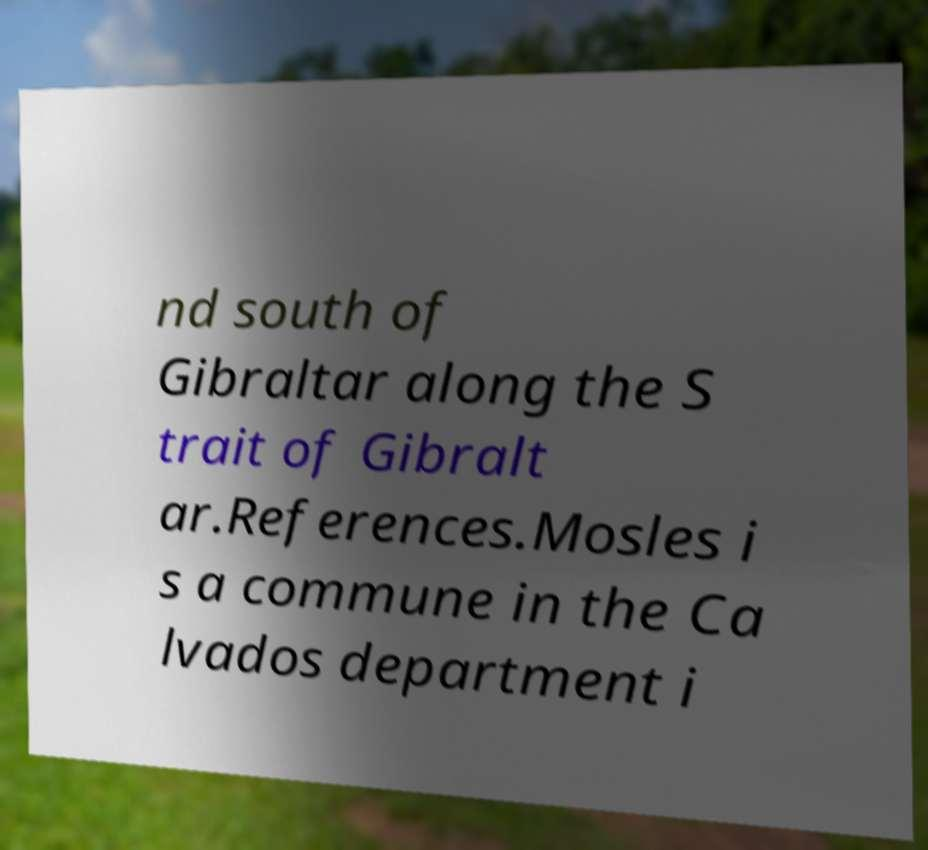Could you extract and type out the text from this image? nd south of Gibraltar along the S trait of Gibralt ar.References.Mosles i s a commune in the Ca lvados department i 